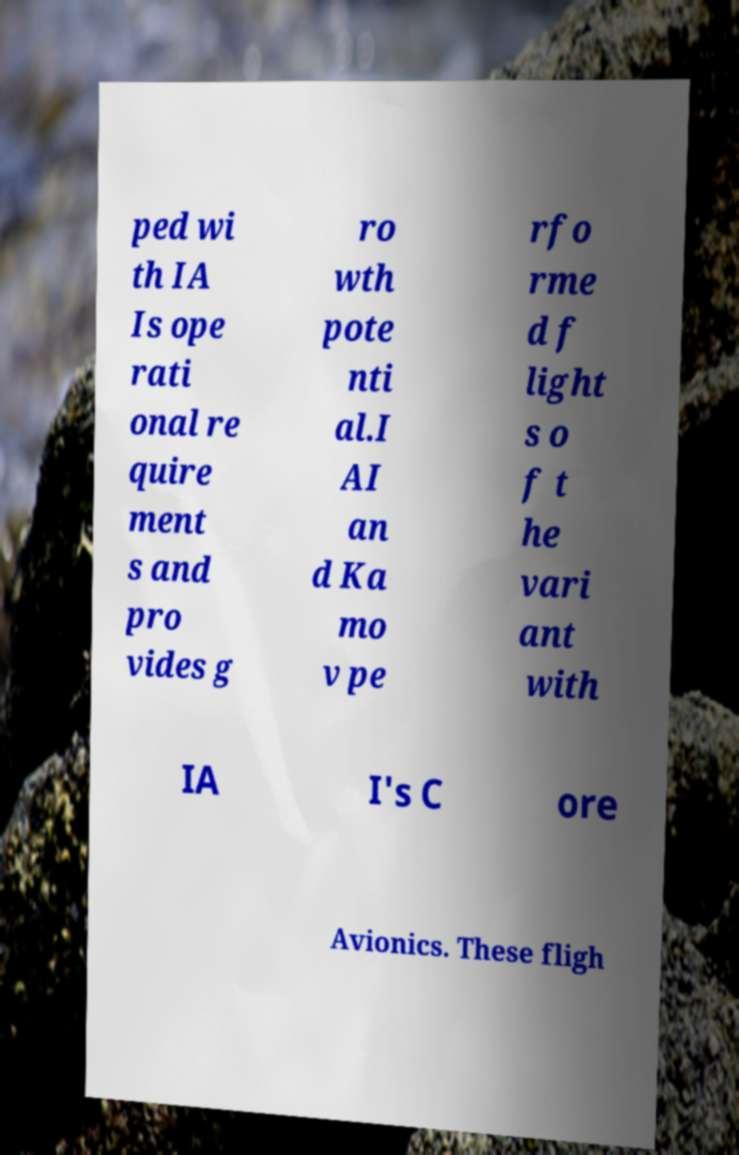What messages or text are displayed in this image? I need them in a readable, typed format. ped wi th IA Is ope rati onal re quire ment s and pro vides g ro wth pote nti al.I AI an d Ka mo v pe rfo rme d f light s o f t he vari ant with IA I's C ore Avionics. These fligh 